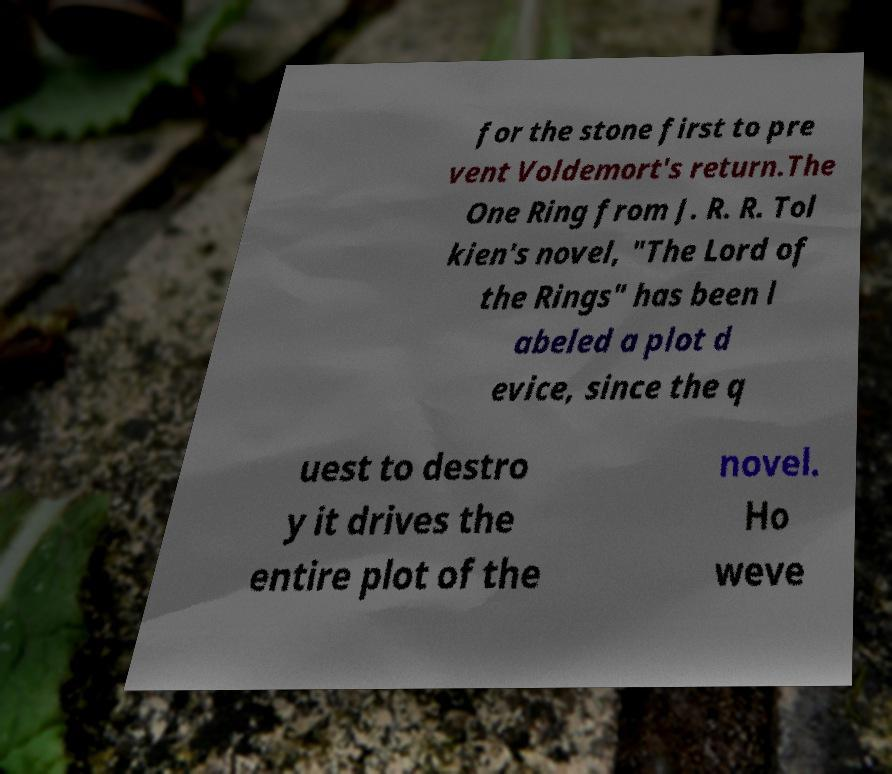Could you assist in decoding the text presented in this image and type it out clearly? for the stone first to pre vent Voldemort's return.The One Ring from J. R. R. Tol kien's novel, "The Lord of the Rings" has been l abeled a plot d evice, since the q uest to destro y it drives the entire plot of the novel. Ho weve 